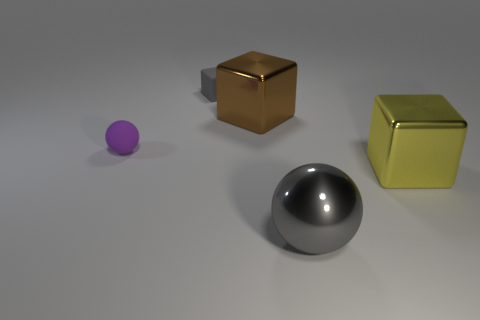Subtract all tiny gray rubber blocks. How many blocks are left? 2 Add 3 small purple matte objects. How many objects exist? 8 Subtract all yellow cubes. How many cubes are left? 2 Subtract all spheres. How many objects are left? 3 Subtract all red cubes. Subtract all purple cylinders. How many cubes are left? 3 Add 4 big metallic spheres. How many big metallic spheres exist? 5 Subtract 0 green cylinders. How many objects are left? 5 Subtract all cubes. Subtract all big blue matte balls. How many objects are left? 2 Add 3 tiny cubes. How many tiny cubes are left? 4 